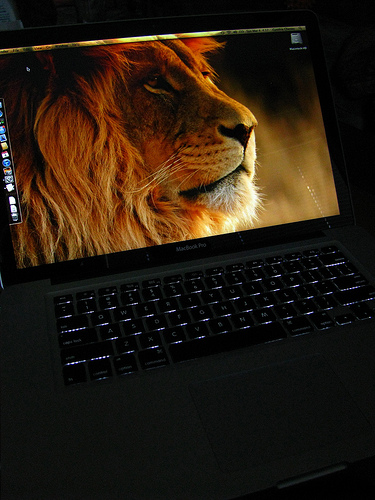<image>
Is the lion on the screen? Yes. Looking at the image, I can see the lion is positioned on top of the screen, with the screen providing support. Where is the lion in relation to the laptop? Is it to the left of the laptop? No. The lion is not to the left of the laptop. From this viewpoint, they have a different horizontal relationship. 